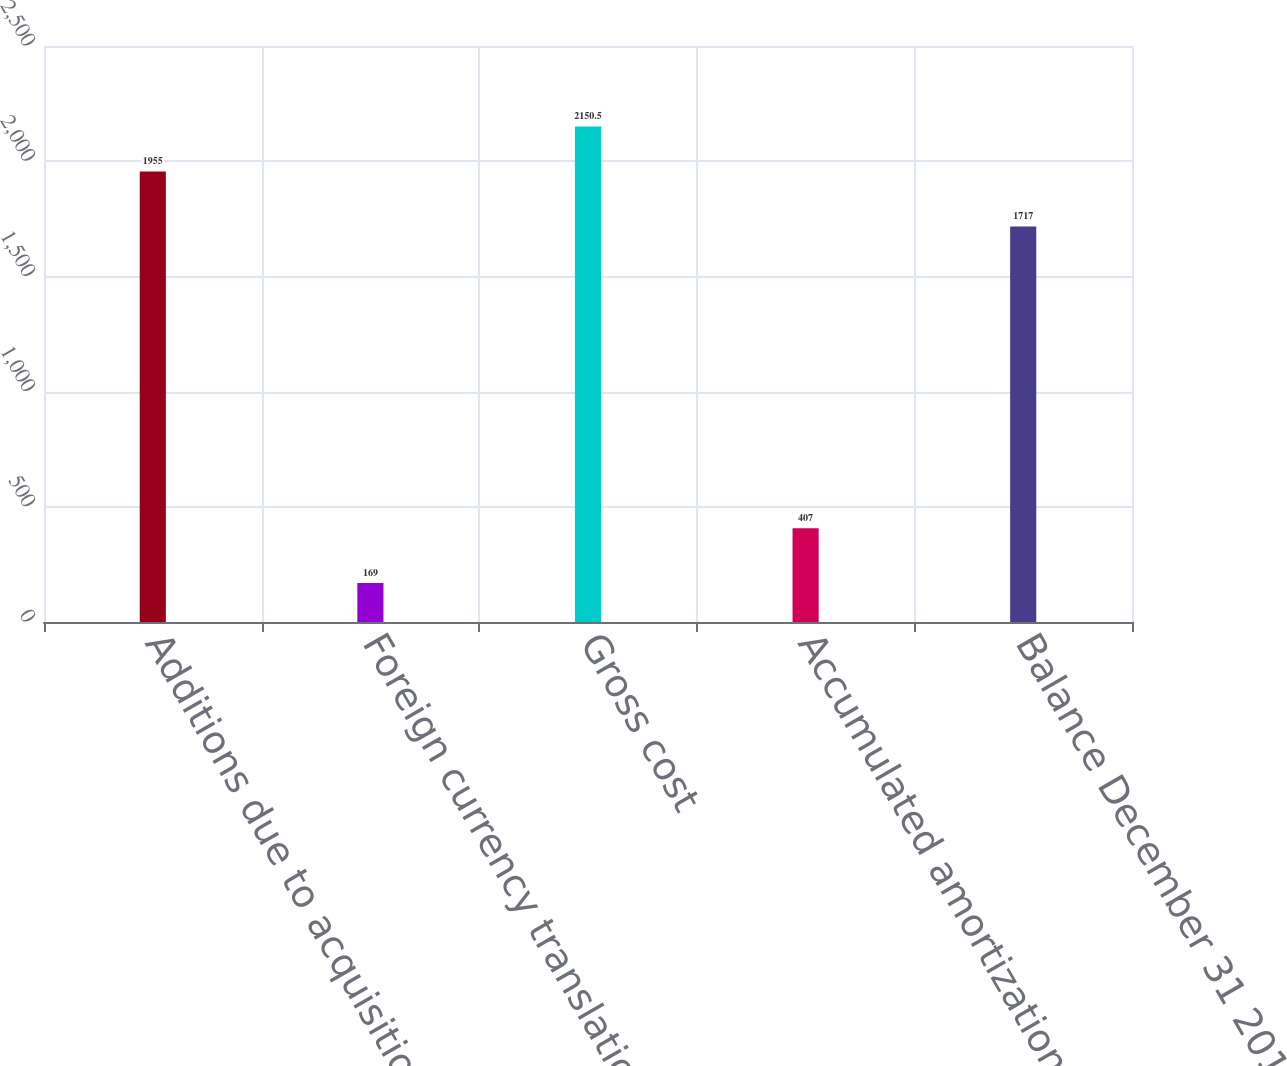Convert chart. <chart><loc_0><loc_0><loc_500><loc_500><bar_chart><fcel>Additions due to acquisition<fcel>Foreign currency translation<fcel>Gross cost<fcel>Accumulated amortization (2)<fcel>Balance December 31 2012<nl><fcel>1955<fcel>169<fcel>2150.5<fcel>407<fcel>1717<nl></chart> 